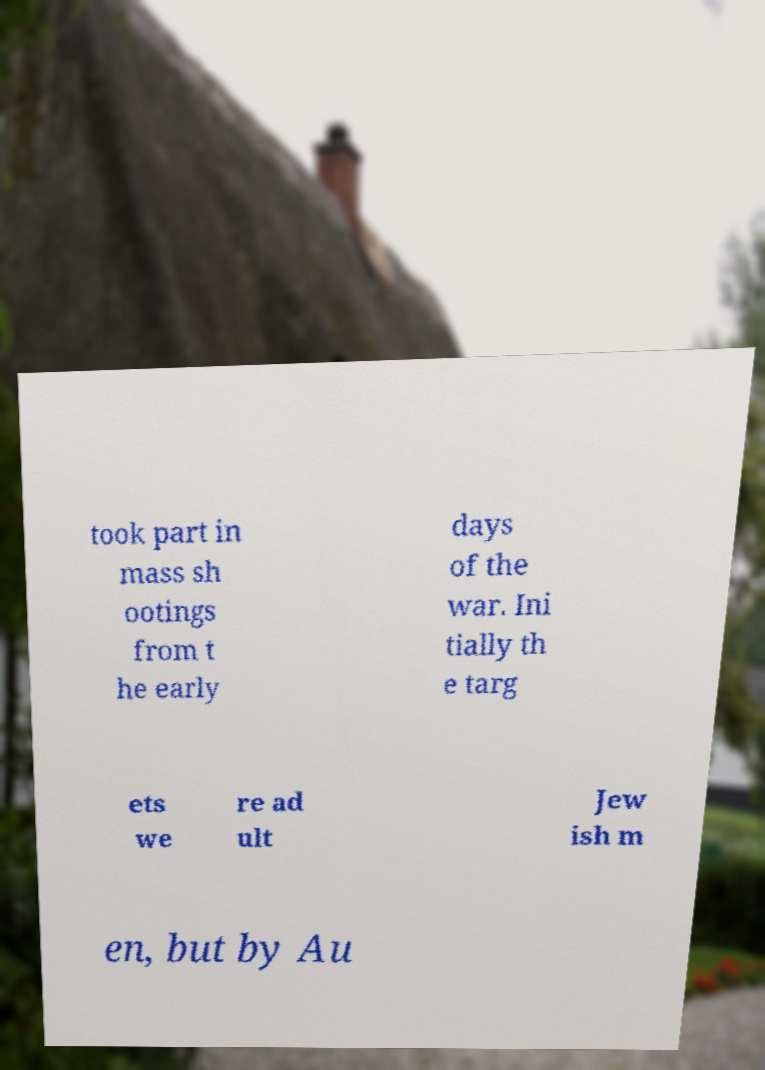Can you read and provide the text displayed in the image?This photo seems to have some interesting text. Can you extract and type it out for me? took part in mass sh ootings from t he early days of the war. Ini tially th e targ ets we re ad ult Jew ish m en, but by Au 